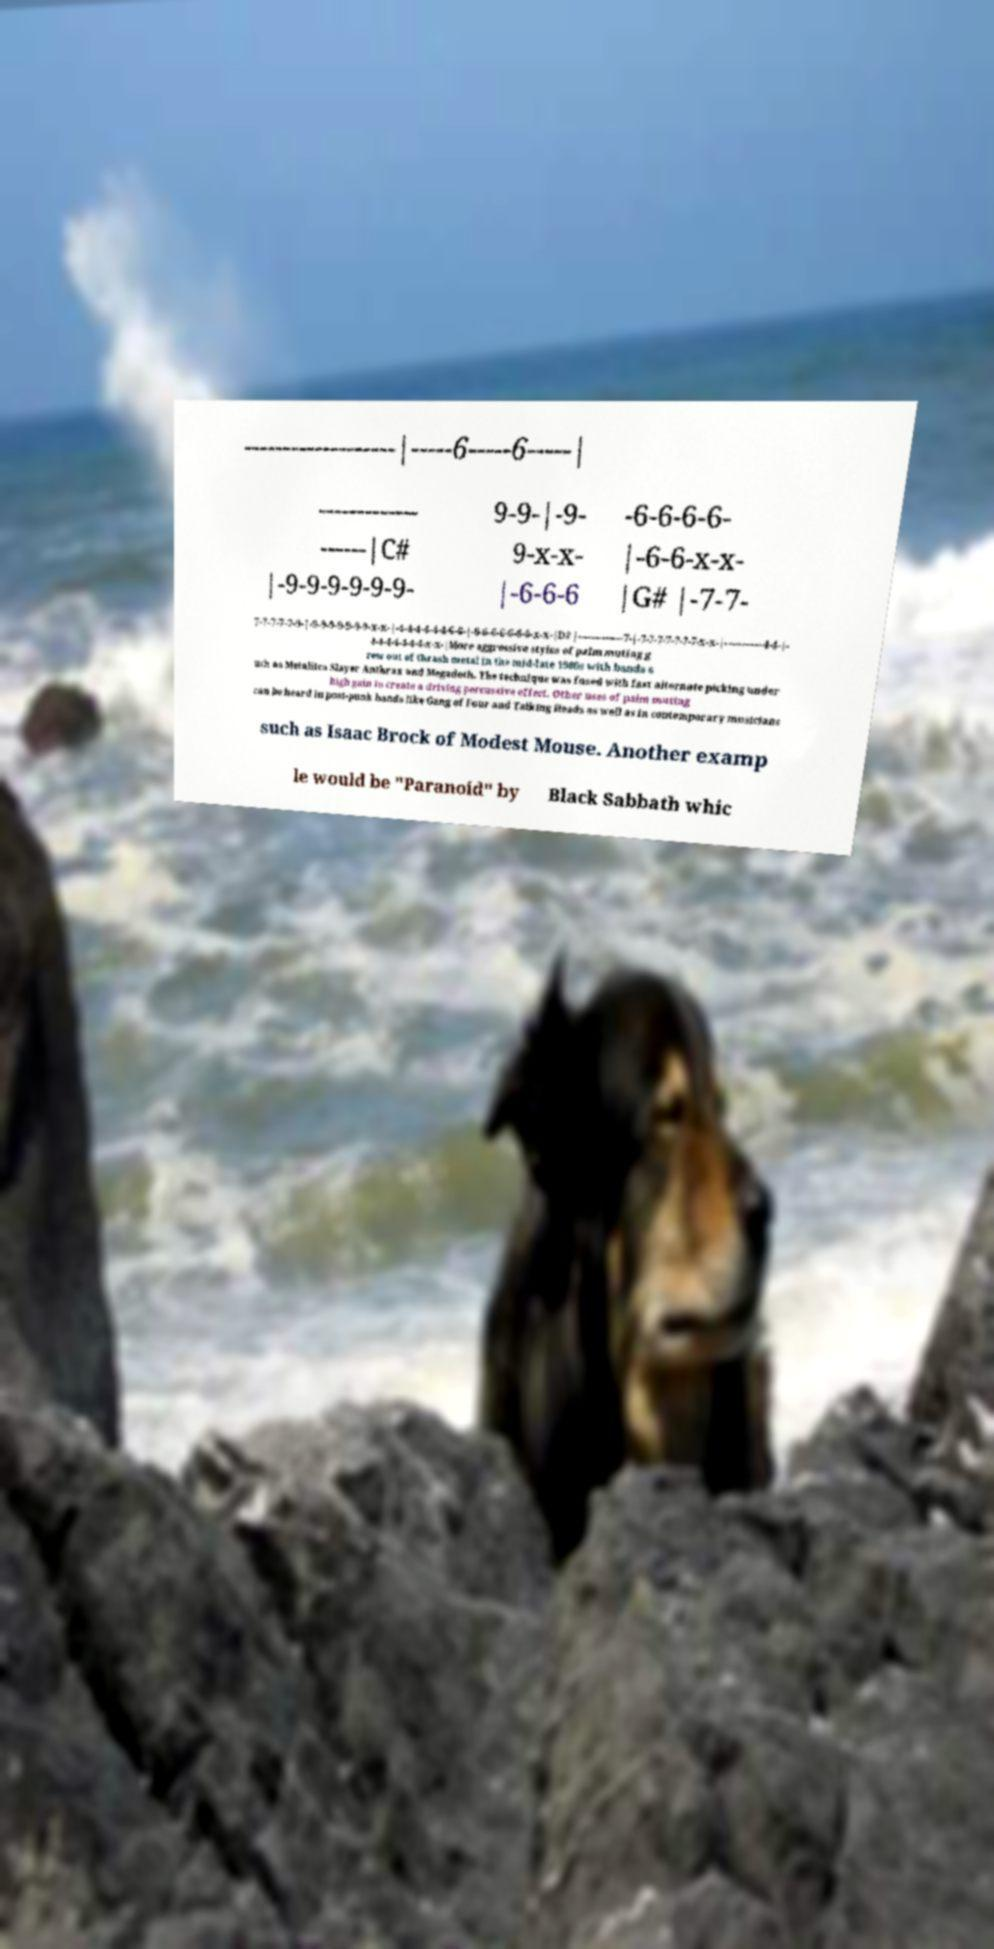Can you read and provide the text displayed in the image?This photo seems to have some interesting text. Can you extract and type it out for me? -------------------|-----6-----6-----| ------------- ------|C# |-9-9-9-9-9-9- 9-9-|-9- 9-x-x- |-6-6-6 -6-6-6-6- |-6-6-x-x- |G# |-7-7- 7-7-7-7-7-9-|-9-9-9-9-9-9-9-x-x-|-4-4-4-4-4-4-6-6-|-6-6-6-6-6-6-6-x-x-|D# |---------------7-|-7-7-7-7-7-7-7-x-x-|-------------4-4-|- 4-4-4-4-4-4-4-x-x-|More aggressive styles of palm muting g rew out of thrash metal in the mid-late 1980s with bands s uch as Metallica Slayer Anthrax and Megadeth. The technique was fused with fast alternate picking under high gain to create a driving percussive effect. Other uses of palm muting can be heard in post-punk bands like Gang of Four and Talking Heads as well as in contemporary musicians such as Isaac Brock of Modest Mouse. Another examp le would be "Paranoid" by Black Sabbath whic 